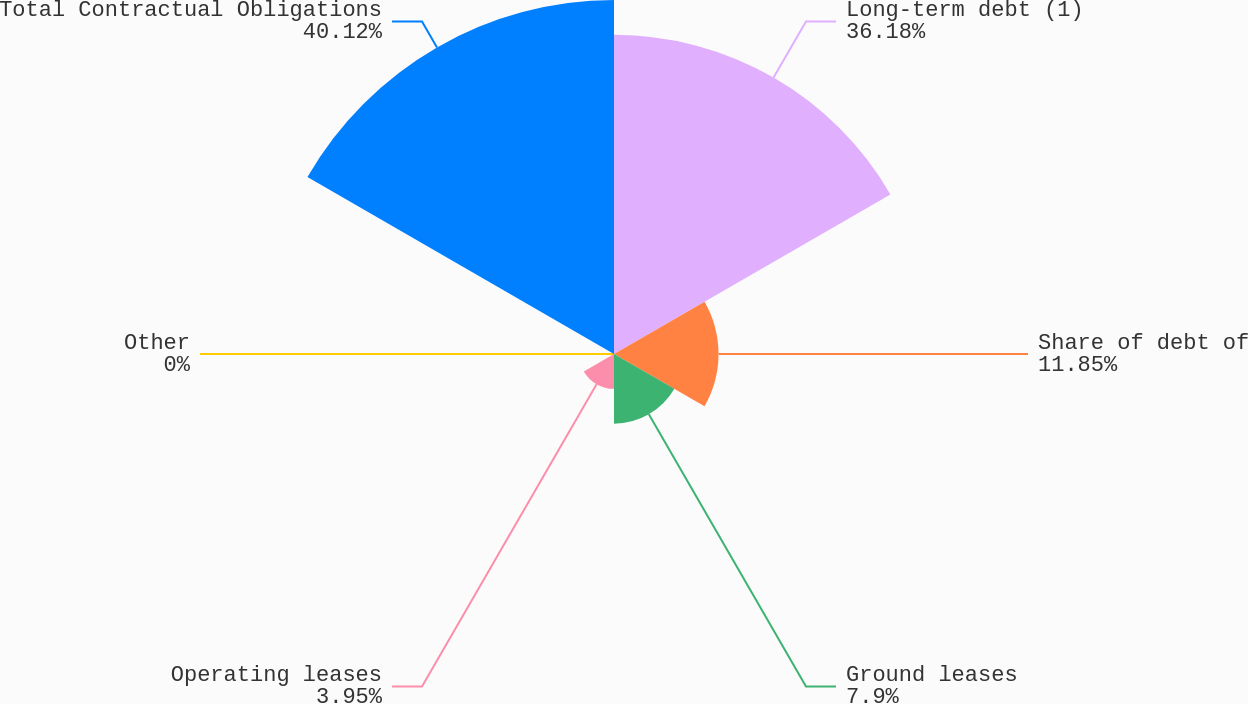Convert chart. <chart><loc_0><loc_0><loc_500><loc_500><pie_chart><fcel>Long-term debt (1)<fcel>Share of debt of<fcel>Ground leases<fcel>Operating leases<fcel>Other<fcel>Total Contractual Obligations<nl><fcel>36.18%<fcel>11.85%<fcel>7.9%<fcel>3.95%<fcel>0.0%<fcel>40.13%<nl></chart> 